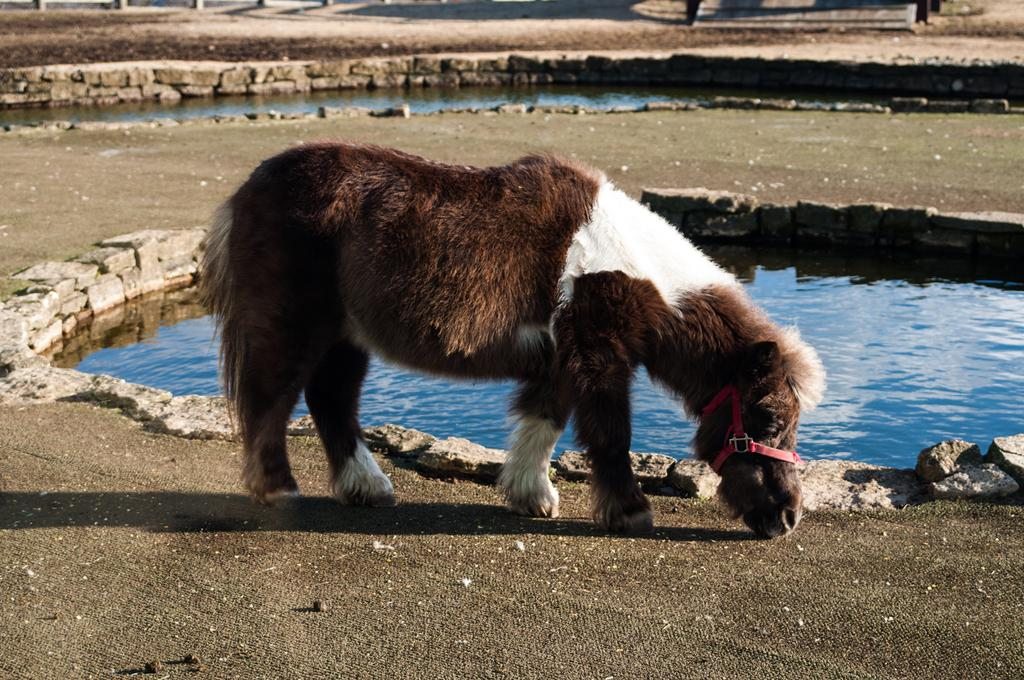What type of animal can be seen in the image? There is an animal standing in the image. What can be seen in the background of the image? There are stones and water visible in the background of the image. How many nails are used to hold the animal's fur in place in the image? There are no nails present in the image, and the animal's fur is not held in place by any nails. 